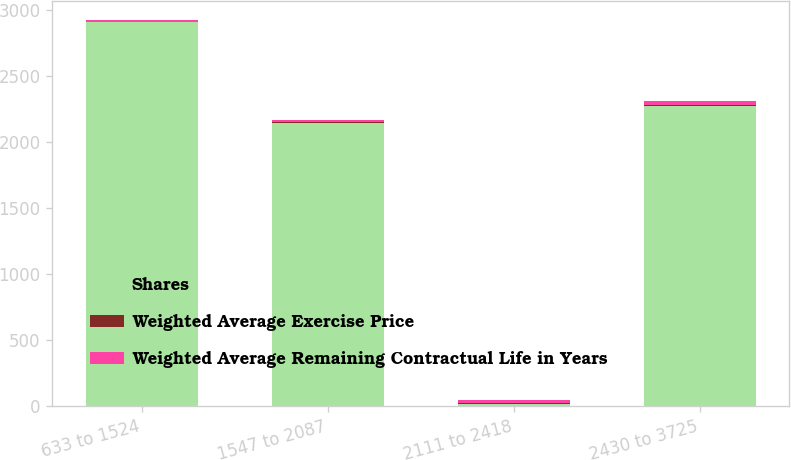Convert chart to OTSL. <chart><loc_0><loc_0><loc_500><loc_500><stacked_bar_chart><ecel><fcel>633 to 1524<fcel>1547 to 2087<fcel>2111 to 2418<fcel>2430 to 3725<nl><fcel>Shares<fcel>2907<fcel>2142<fcel>18.16<fcel>2276<nl><fcel>Weighted Average Exercise Price<fcel>4.7<fcel>6.7<fcel>7.9<fcel>7.5<nl><fcel>Weighted Average Remaining Contractual Life in Years<fcel>13.22<fcel>18.16<fcel>21.73<fcel>25.85<nl></chart> 